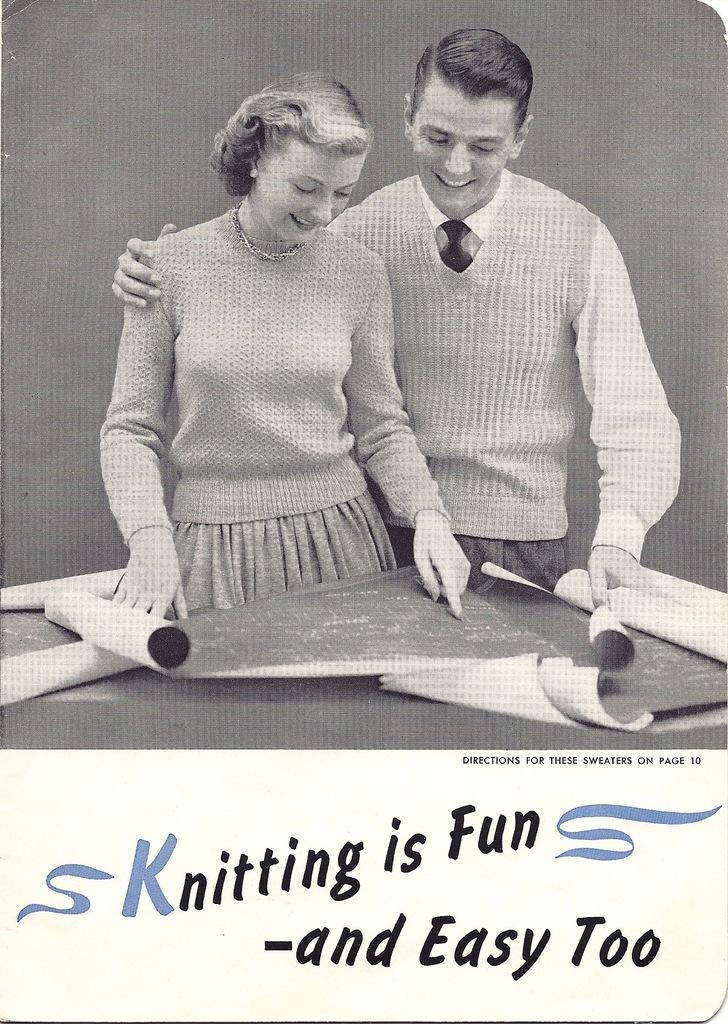Who are the people in the image? There is a man and a woman in the image. What are the man and woman holding? The man and woman are holding charts. What can be seen at the bottom of the image? There is text visible at the bottom of the image. What color scheme is used in the image? The image is in black and white color. Can you see a snail crawling on the charts in the image? No, there is no snail present in the image. What type of silk is being used to create the charts in the image? The image does not show any silk being used; it only shows the man and woman holding charts. 